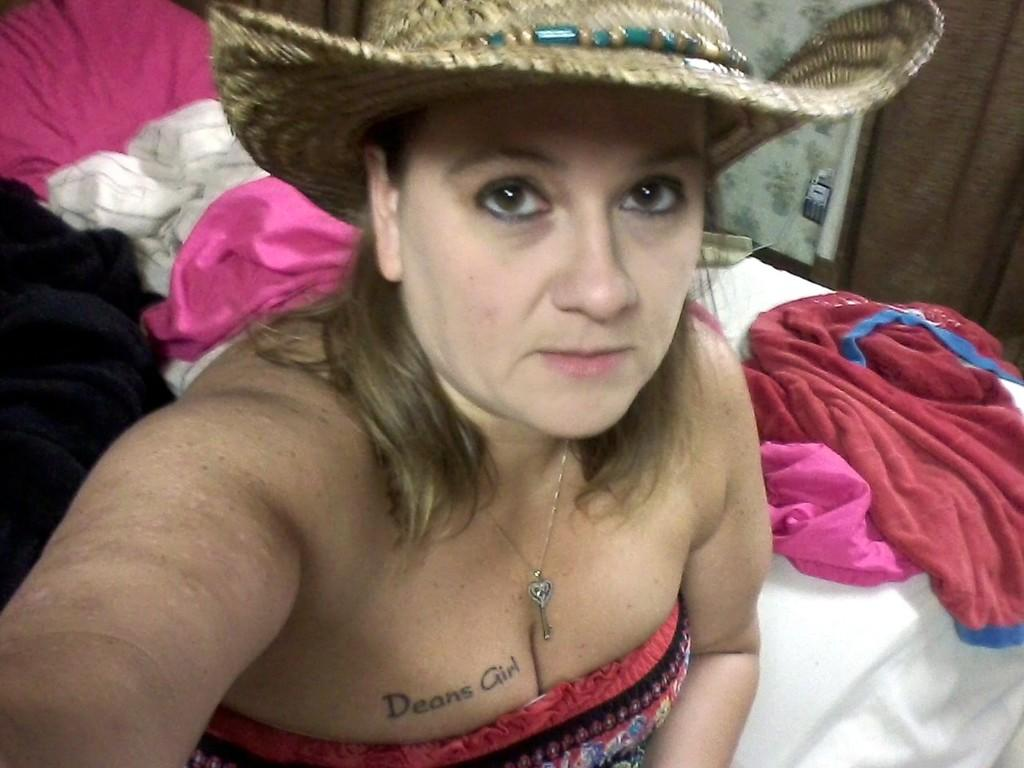Who is the main subject in the image? There is a lady in the center of the image. What is the lady wearing on her head? The lady is wearing a hat. What can be seen in the background of the image? There are clothes in the background of the image. What type of tail can be seen on the lady in the image? There is no tail visible on the lady in the image. What type of lace is used to decorate the clothes in the background? There is no information about the type of lace used to decorate the clothes in the image. 